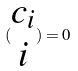Convert formula to latex. <formula><loc_0><loc_0><loc_500><loc_500>( \begin{matrix} c _ { i } \\ i \end{matrix} ) = 0</formula> 